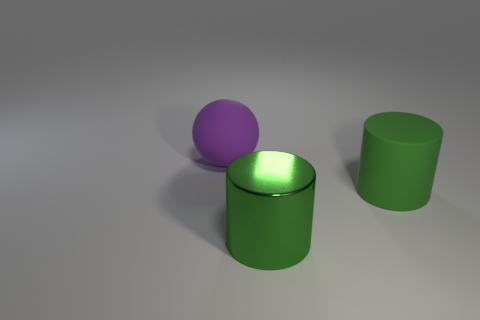Add 2 green metallic spheres. How many objects exist? 5 Subtract 1 balls. How many balls are left? 0 Subtract all cyan cylinders. Subtract all blue blocks. How many cylinders are left? 2 Subtract all brown spheres. How many yellow cylinders are left? 0 Subtract all purple spheres. Subtract all large green objects. How many objects are left? 0 Add 1 large rubber objects. How many large rubber objects are left? 3 Add 2 gray cubes. How many gray cubes exist? 2 Subtract 0 yellow cylinders. How many objects are left? 3 Subtract all cylinders. How many objects are left? 1 